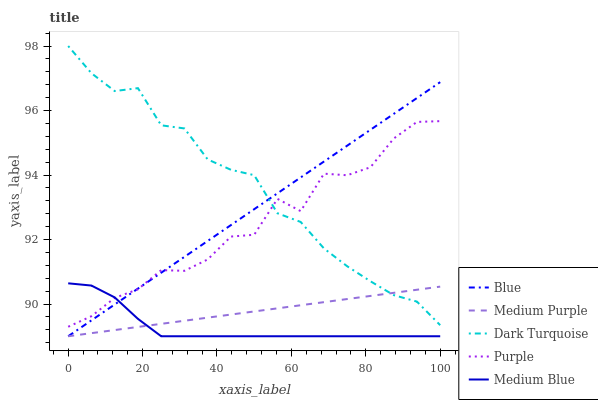Does Medium Blue have the minimum area under the curve?
Answer yes or no. Yes. Does Dark Turquoise have the maximum area under the curve?
Answer yes or no. Yes. Does Medium Purple have the minimum area under the curve?
Answer yes or no. No. Does Medium Purple have the maximum area under the curve?
Answer yes or no. No. Is Medium Purple the smoothest?
Answer yes or no. Yes. Is Purple the roughest?
Answer yes or no. Yes. Is Medium Blue the smoothest?
Answer yes or no. No. Is Medium Blue the roughest?
Answer yes or no. No. Does Purple have the lowest value?
Answer yes or no. No. Does Dark Turquoise have the highest value?
Answer yes or no. Yes. Does Medium Blue have the highest value?
Answer yes or no. No. Is Medium Purple less than Purple?
Answer yes or no. Yes. Is Purple greater than Medium Purple?
Answer yes or no. Yes. Does Dark Turquoise intersect Purple?
Answer yes or no. Yes. Is Dark Turquoise less than Purple?
Answer yes or no. No. Is Dark Turquoise greater than Purple?
Answer yes or no. No. Does Medium Purple intersect Purple?
Answer yes or no. No. 